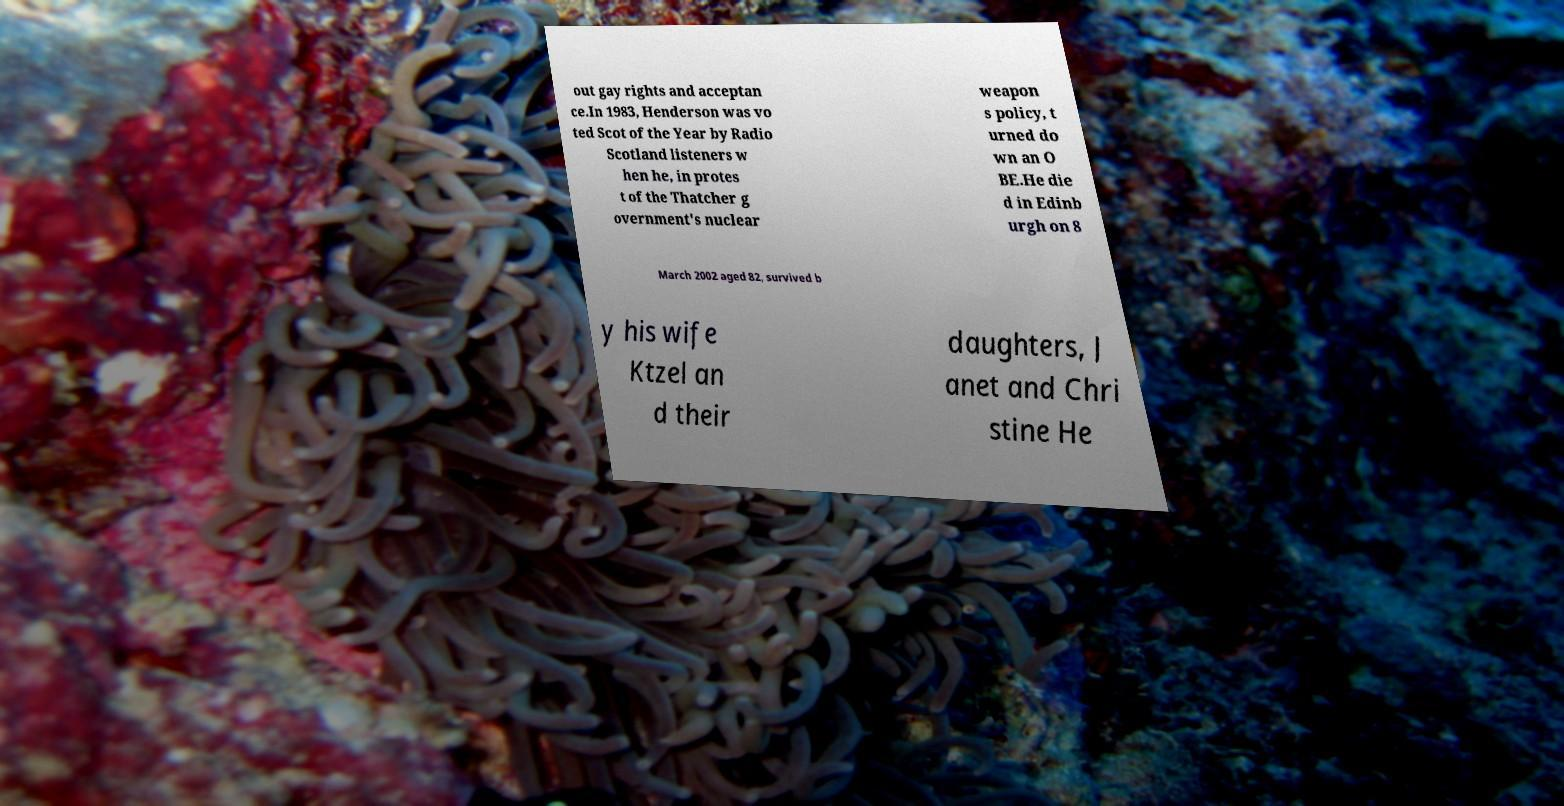There's text embedded in this image that I need extracted. Can you transcribe it verbatim? out gay rights and acceptan ce.In 1983, Henderson was vo ted Scot of the Year by Radio Scotland listeners w hen he, in protes t of the Thatcher g overnment's nuclear weapon s policy, t urned do wn an O BE.He die d in Edinb urgh on 8 March 2002 aged 82, survived b y his wife Ktzel an d their daughters, J anet and Chri stine He 